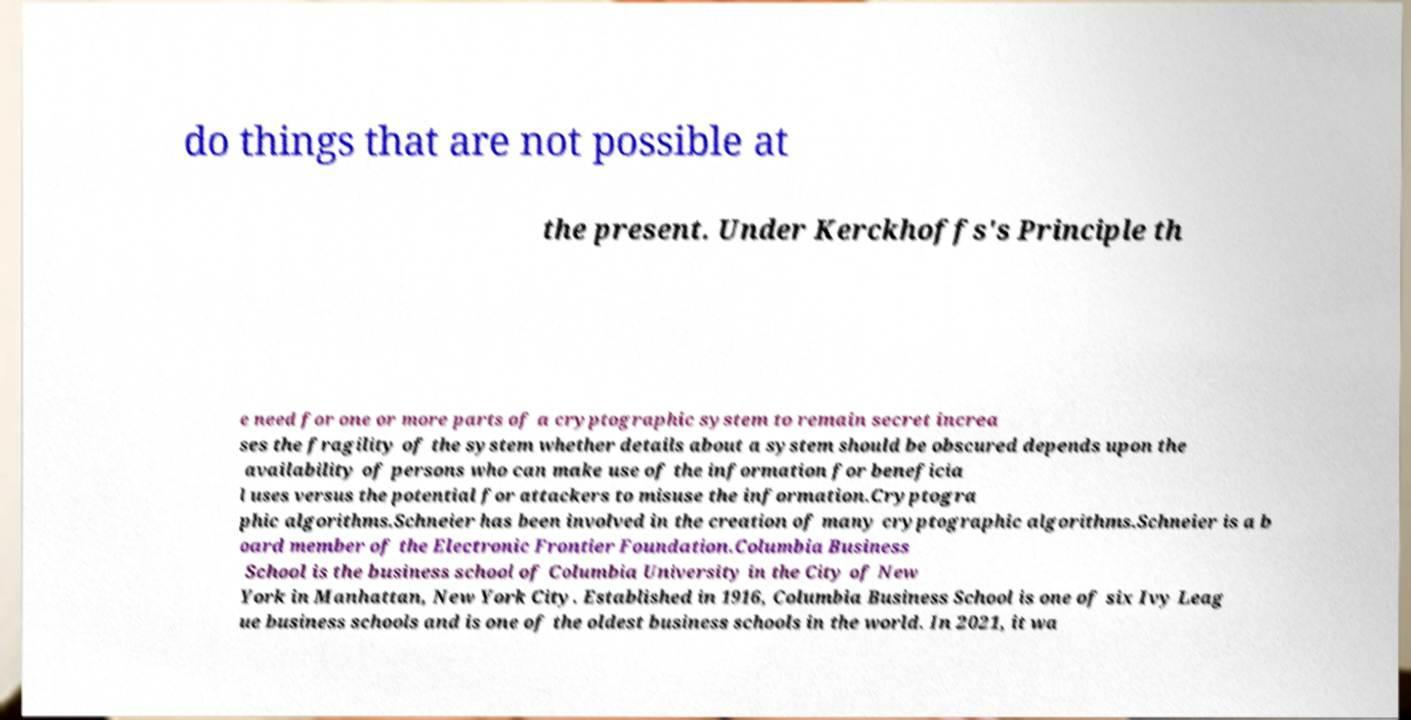Can you accurately transcribe the text from the provided image for me? do things that are not possible at the present. Under Kerckhoffs's Principle th e need for one or more parts of a cryptographic system to remain secret increa ses the fragility of the system whether details about a system should be obscured depends upon the availability of persons who can make use of the information for beneficia l uses versus the potential for attackers to misuse the information.Cryptogra phic algorithms.Schneier has been involved in the creation of many cryptographic algorithms.Schneier is a b oard member of the Electronic Frontier Foundation.Columbia Business School is the business school of Columbia University in the City of New York in Manhattan, New York City. Established in 1916, Columbia Business School is one of six Ivy Leag ue business schools and is one of the oldest business schools in the world. In 2021, it wa 